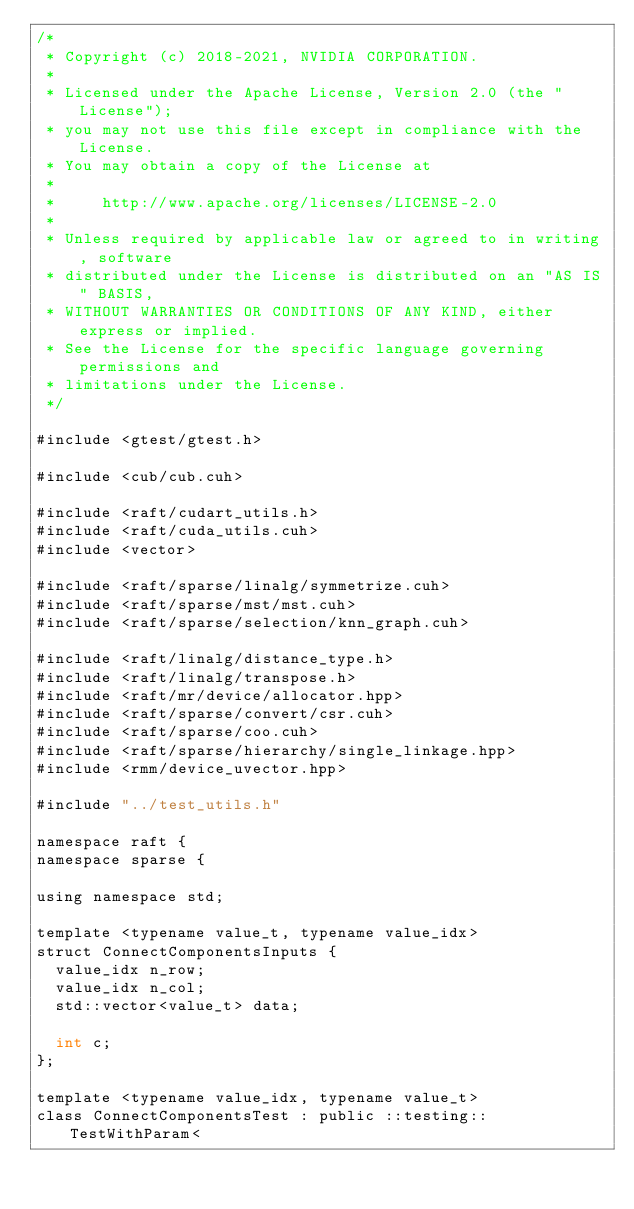<code> <loc_0><loc_0><loc_500><loc_500><_Cuda_>/*
 * Copyright (c) 2018-2021, NVIDIA CORPORATION.
 *
 * Licensed under the Apache License, Version 2.0 (the "License");
 * you may not use this file except in compliance with the License.
 * You may obtain a copy of the License at
 *
 *     http://www.apache.org/licenses/LICENSE-2.0
 *
 * Unless required by applicable law or agreed to in writing, software
 * distributed under the License is distributed on an "AS IS" BASIS,
 * WITHOUT WARRANTIES OR CONDITIONS OF ANY KIND, either express or implied.
 * See the License for the specific language governing permissions and
 * limitations under the License.
 */

#include <gtest/gtest.h>

#include <cub/cub.cuh>

#include <raft/cudart_utils.h>
#include <raft/cuda_utils.cuh>
#include <vector>

#include <raft/sparse/linalg/symmetrize.cuh>
#include <raft/sparse/mst/mst.cuh>
#include <raft/sparse/selection/knn_graph.cuh>

#include <raft/linalg/distance_type.h>
#include <raft/linalg/transpose.h>
#include <raft/mr/device/allocator.hpp>
#include <raft/sparse/convert/csr.cuh>
#include <raft/sparse/coo.cuh>
#include <raft/sparse/hierarchy/single_linkage.hpp>
#include <rmm/device_uvector.hpp>

#include "../test_utils.h"

namespace raft {
namespace sparse {

using namespace std;

template <typename value_t, typename value_idx>
struct ConnectComponentsInputs {
  value_idx n_row;
  value_idx n_col;
  std::vector<value_t> data;

  int c;
};

template <typename value_idx, typename value_t>
class ConnectComponentsTest : public ::testing::TestWithParam<</code> 